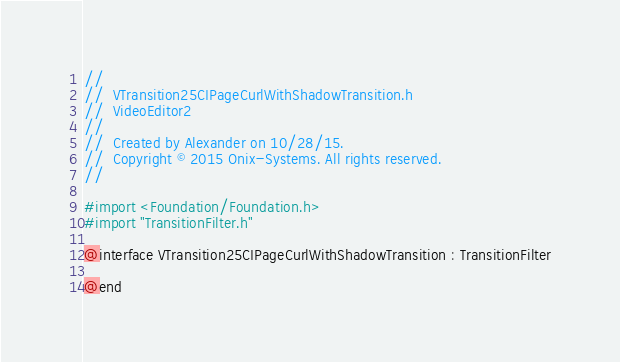Convert code to text. <code><loc_0><loc_0><loc_500><loc_500><_C_>//
//  VTransition25CIPageCurlWithShadowTransition.h
//  VideoEditor2
//
//  Created by Alexander on 10/28/15.
//  Copyright © 2015 Onix-Systems. All rights reserved.
//

#import <Foundation/Foundation.h>
#import "TransitionFilter.h"

@interface VTransition25CIPageCurlWithShadowTransition : TransitionFilter

@end
</code> 